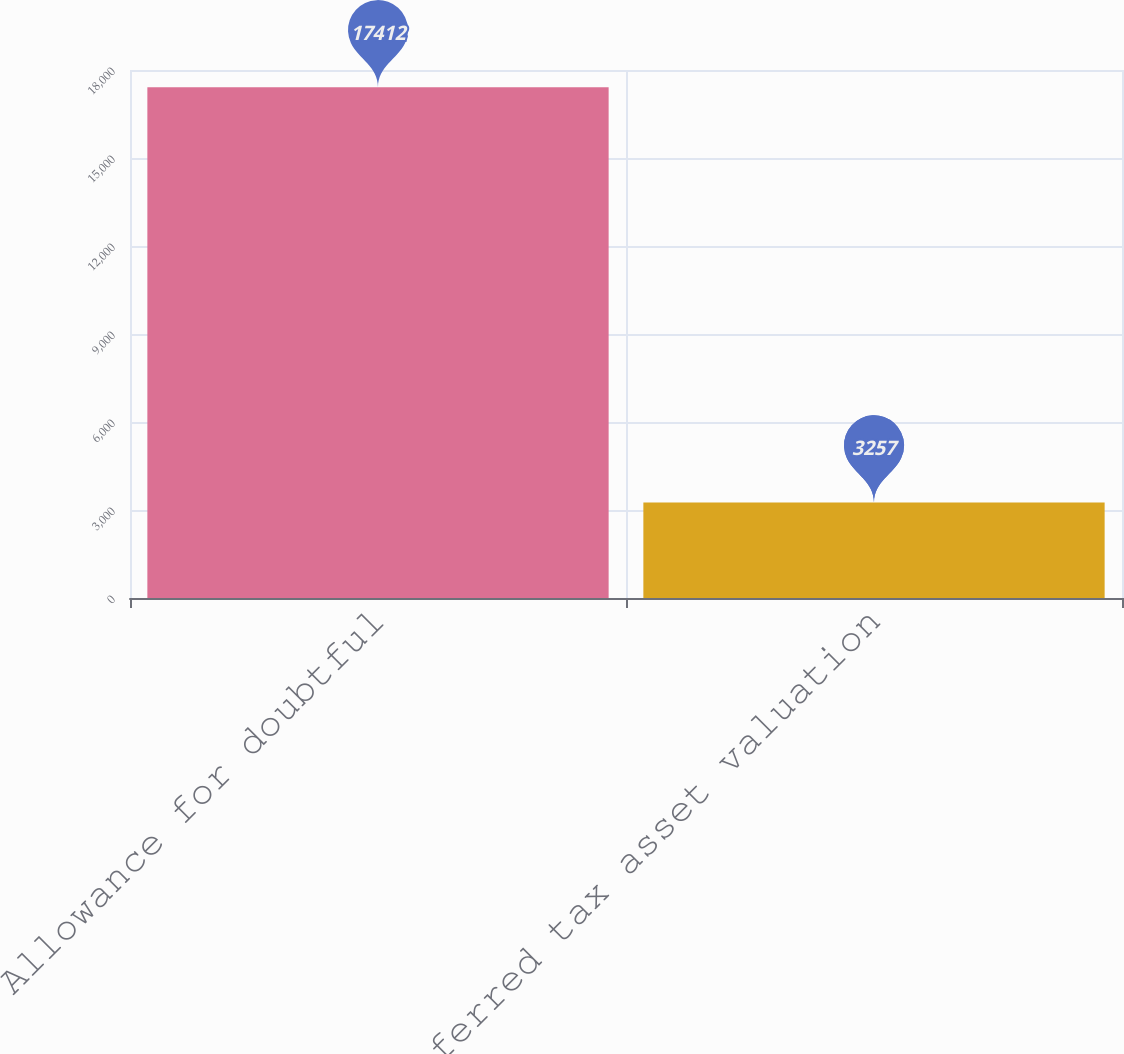<chart> <loc_0><loc_0><loc_500><loc_500><bar_chart><fcel>Allowance for doubtful<fcel>Deferred tax asset valuation<nl><fcel>17412<fcel>3257<nl></chart> 